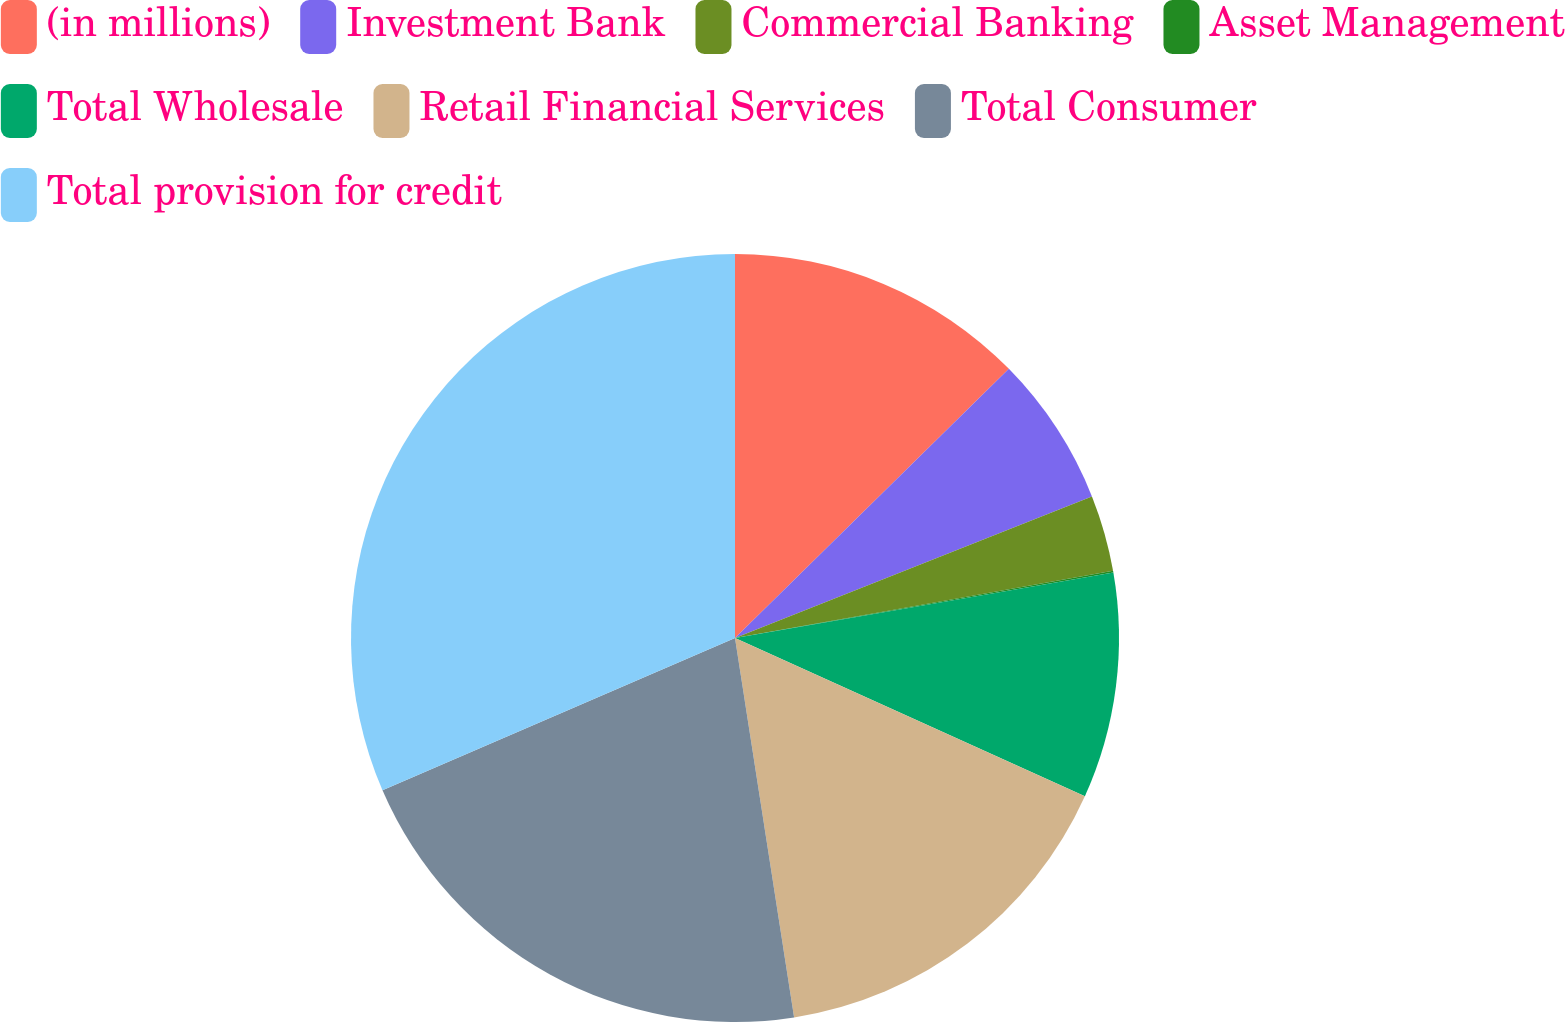Convert chart to OTSL. <chart><loc_0><loc_0><loc_500><loc_500><pie_chart><fcel>(in millions)<fcel>Investment Bank<fcel>Commercial Banking<fcel>Asset Management<fcel>Total Wholesale<fcel>Retail Financial Services<fcel>Total Consumer<fcel>Total provision for credit<nl><fcel>12.64%<fcel>6.35%<fcel>3.21%<fcel>0.07%<fcel>9.49%<fcel>15.78%<fcel>20.97%<fcel>31.49%<nl></chart> 